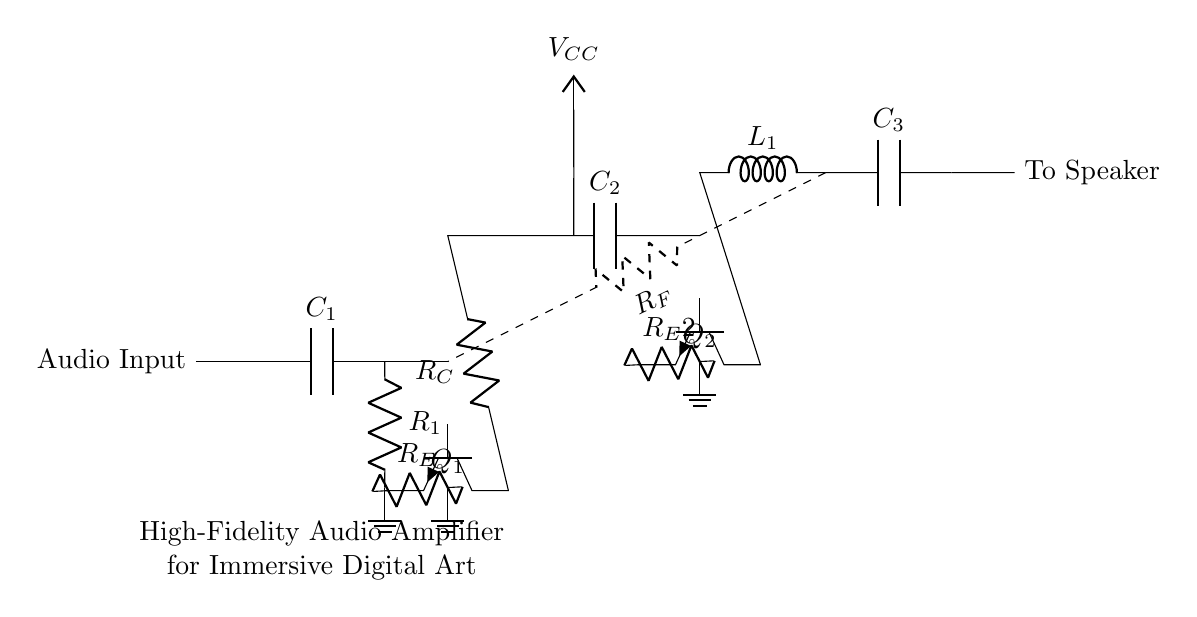What is the type of amplifier depicted? The circuit diagram represents a high-fidelity audio amplifier, as indicated by the labels and components designed for audio signal amplification.
Answer: high-fidelity audio amplifier What is the role of component R1? R1 is used as a resistor in the pre-amplifier stage, helping to set the gain and stability of the amplifier circuit by affecting the voltage across it and the base-emitter voltage of the transistor Q1.
Answer: set gain What is the purpose of C2 in the circuit? C2 acts as a coupling capacitor between the pre-amplifier and power amplifier stages, allowing AC signals to pass while blocking DC from affecting the next stage of amplification.
Answer: coupling capacitor How many transistors are in the circuit? The circuit contains two transistors, Q1 and Q2, which are used in the pre-amplifier and power amplifier stages respectively to amplify the audio signal.
Answer: two What are the values of R_E and R_E2 used for? R_E and R_E2 are emitter resistors that provide feedback and stability to the transistors Q1 and Q2. They help improve linearity and thermal stability of the circuit by stabilizing the operating point.
Answer: feedback and stability What is the significance of L1 in the circuit? L1 is an inductor that works as part of the output stage, contributing to impedance matching with the speaker and filtering, enhancing the overall audio performance by allowing for better low-frequency response.
Answer: impedance matching What does the dashed line represent in the circuit? The dashed line represents the feedback path through resistor R_F, which connects the output to the input stage of the amplifier, facilitating negative feedback to improve quality and reduce distortion in the amplification process.
Answer: feedback path 